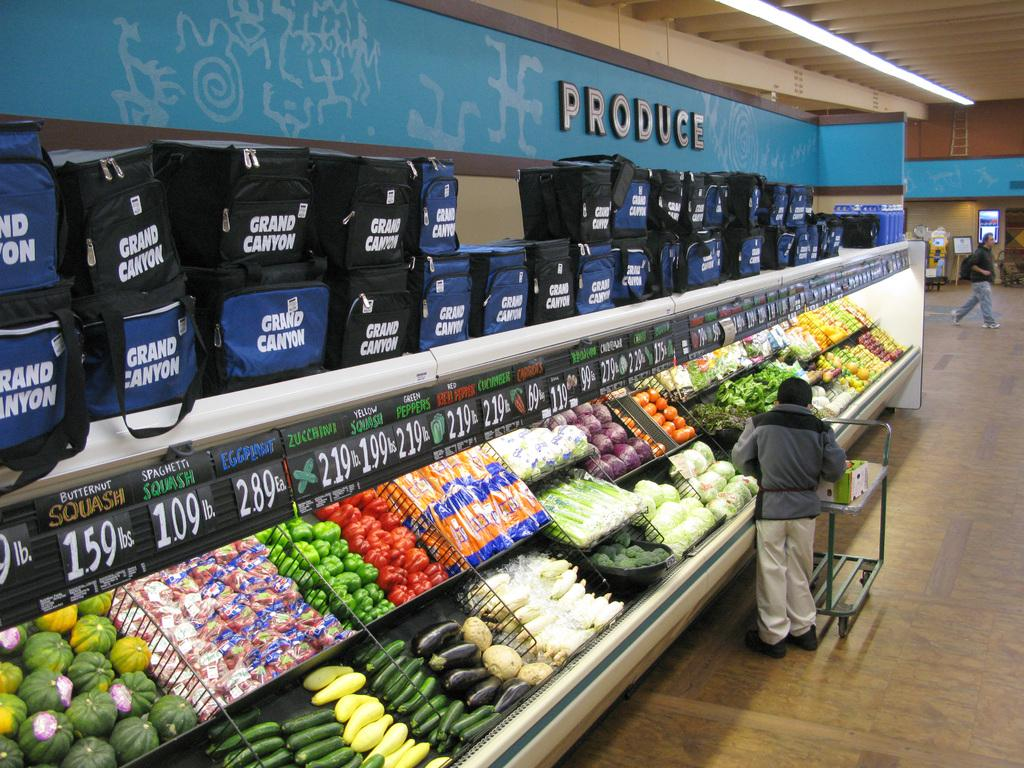<image>
Relay a brief, clear account of the picture shown. The produce section at this grocery store has a bunch of bags that say "Grand Canyon" piled on top of the shelves. 